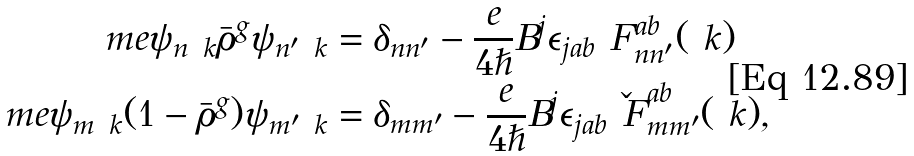<formula> <loc_0><loc_0><loc_500><loc_500>\ m e { \psi _ { n \ k } } { \bar { \rho } ^ { g } } { \psi _ { n ^ { \prime } \ k } } & = \delta _ { n n ^ { \prime } } - \frac { e } { 4 \hslash } B ^ { j } \epsilon _ { j a b } \ F ^ { a b } _ { n n ^ { \prime } } ( \ k ) \\ \ m e { \psi _ { m \ k } } { ( 1 - \bar { \rho } ^ { g } ) } { \psi _ { m ^ { \prime } \ k } } & = \delta _ { m m ^ { \prime } } - \frac { e } { 4 \hslash } B ^ { j } \epsilon _ { j a b } \check { \ F } ^ { a b } _ { m m ^ { \prime } } ( \ k ) ,</formula> 